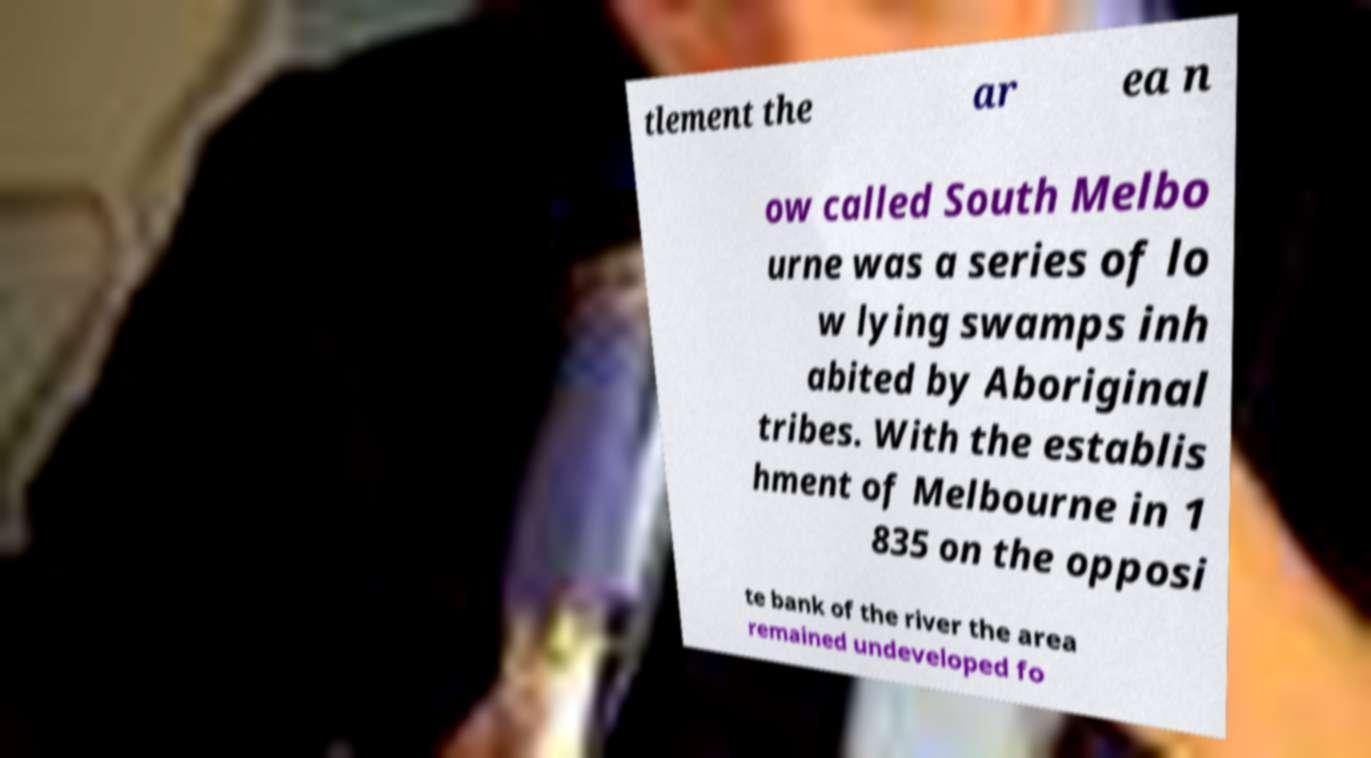Can you accurately transcribe the text from the provided image for me? tlement the ar ea n ow called South Melbo urne was a series of lo w lying swamps inh abited by Aboriginal tribes. With the establis hment of Melbourne in 1 835 on the opposi te bank of the river the area remained undeveloped fo 